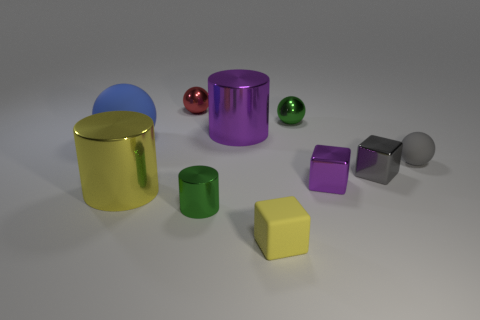Subtract all large purple metal cylinders. How many cylinders are left? 2 Subtract 2 spheres. How many spheres are left? 2 Subtract all gray balls. How many balls are left? 3 Subtract all spheres. How many objects are left? 6 Add 4 green things. How many green things exist? 6 Subtract 0 blue cylinders. How many objects are left? 10 Subtract all gray spheres. Subtract all green cubes. How many spheres are left? 3 Subtract all large yellow cylinders. Subtract all blue things. How many objects are left? 8 Add 5 small matte spheres. How many small matte spheres are left? 6 